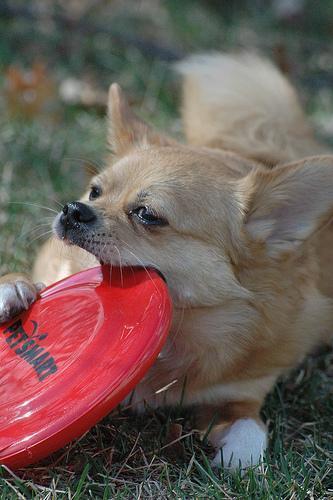How many dogs?
Give a very brief answer. 1. 